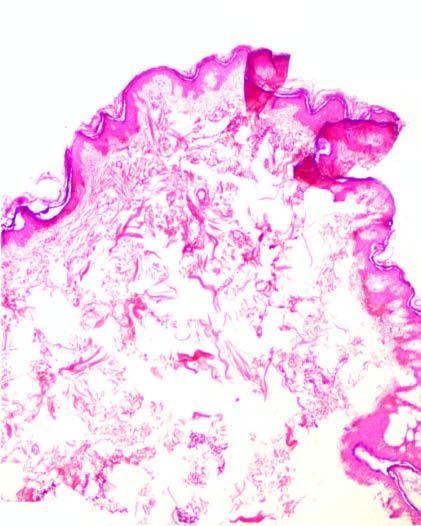s cut surface raised as polypoid mass over dense hyalinised fibrous connective tissue in the dermis?
Answer the question using a single word or phrase. No 